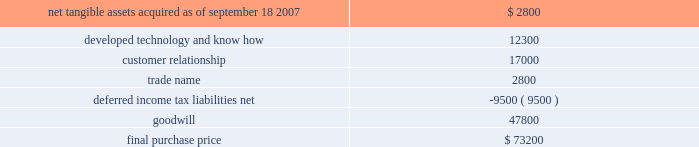Hologic , inc .
Notes to consolidated financial statements ( continued ) ( in thousands , except per share data ) fiscal 2007 acquisition : acquisition of biolucent , inc .
On september 18 , 2007 the company completed the acquisition of biolucent , inc .
( 201cbiolucent 201d ) pursuant to a definitive agreement dated june 20 , 2007 .
The results of operations for biolucent have been included in the company 2019s consolidated financial statements from the date of acquisition as part of its mammography/breast care business segment .
The company has concluded that the acquisition of biolucent does not represent a material business combination and therefore no pro forma financial information has been provided herein .
Biolucent , previously located in aliso viejo , california , develops , markets and sells mammopad breast cushions to decrease the discomfort associated with mammography .
Prior to the acquisition , biolucent 2019s primary research and development efforts were directed at its brachytherapy business which was focused on breast cancer therapy .
Prior to the acquisition , biolucent spun-off its brachytherapy technology and business to the holders of biolucent 2019s outstanding shares of capital stock .
As a result , the company only acquired biolucent 2019s mammopad cushion business and related assets .
The company invested $ 1000 directly in the spun-off brachytherapy business in exchange for shares of preferred stock issued by the new business .
The aggregate purchase price for biolucent was approximately $ 73200 , consisting of approximately $ 6800 in cash and 2314 shares of hologic common stock valued at approximately $ 63200 , debt assumed and paid off of approximately $ 1600 and approximately $ 1600 for acquisition related fees and expenses .
The company determined the fair value of the shares issued in connection with the acquisition in accordance with eitf issue no .
99-12 , determination of the measurement date for the market price of acquirer securities issued in a purchase business combination .
The acquisition also provides for up to two annual earn-out payments not to exceed $ 15000 in the aggregate based on biolucent 2019s achievement of certain revenue targets .
The company has considered the provision of eitf issue no .
95-8 , accounting for contingent consideration paid to the shareholders of an acquired enterprise in a purchase business combination , and concluded that this contingent consideration will represent additional purchase price .
As a result , goodwill will be increased by the amount of the additional consideration , if any , when it becomes due and payable .
As of september 27 , 2008 , the company has not recorded any amounts for these potential earn-outs .
The allocation of the purchase price is based upon estimates of the fair value of assets acquired and liabilities assumed as of september 18 , 2007 .
The components and allocation of the purchase price consists of the following approximate amounts: .
As part of the purchase price allocation , all intangible assets that were a part of the acquisition were identified and valued .
It was determined that only customer relationship , trade name and developed technology and know-how had separately identifiable values .
The fair value of these intangible assets was determined through the application of the income approach .
Customer relationship represents a large customer base that is expected to purchase the disposable mammopad product on a regular basis .
Trade name represents the .
What portion of the final purchase price of biolucent is dedicated to goodwill? 
Computations: (47800 / 73200)
Answer: 0.65301. 